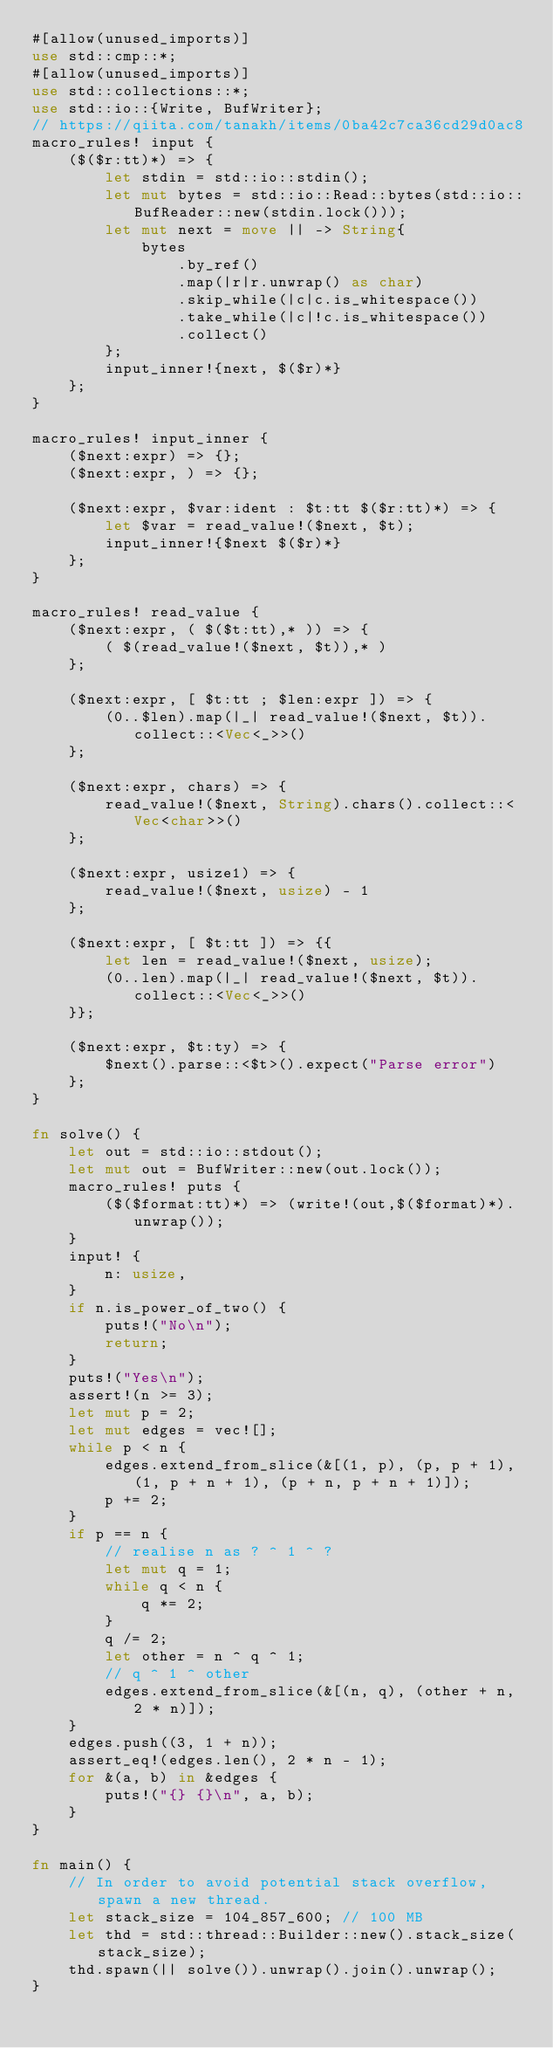<code> <loc_0><loc_0><loc_500><loc_500><_Rust_>#[allow(unused_imports)]
use std::cmp::*;
#[allow(unused_imports)]
use std::collections::*;
use std::io::{Write, BufWriter};
// https://qiita.com/tanakh/items/0ba42c7ca36cd29d0ac8
macro_rules! input {
    ($($r:tt)*) => {
        let stdin = std::io::stdin();
        let mut bytes = std::io::Read::bytes(std::io::BufReader::new(stdin.lock()));
        let mut next = move || -> String{
            bytes
                .by_ref()
                .map(|r|r.unwrap() as char)
                .skip_while(|c|c.is_whitespace())
                .take_while(|c|!c.is_whitespace())
                .collect()
        };
        input_inner!{next, $($r)*}
    };
}

macro_rules! input_inner {
    ($next:expr) => {};
    ($next:expr, ) => {};

    ($next:expr, $var:ident : $t:tt $($r:tt)*) => {
        let $var = read_value!($next, $t);
        input_inner!{$next $($r)*}
    };
}

macro_rules! read_value {
    ($next:expr, ( $($t:tt),* )) => {
        ( $(read_value!($next, $t)),* )
    };

    ($next:expr, [ $t:tt ; $len:expr ]) => {
        (0..$len).map(|_| read_value!($next, $t)).collect::<Vec<_>>()
    };

    ($next:expr, chars) => {
        read_value!($next, String).chars().collect::<Vec<char>>()
    };

    ($next:expr, usize1) => {
        read_value!($next, usize) - 1
    };

    ($next:expr, [ $t:tt ]) => {{
        let len = read_value!($next, usize);
        (0..len).map(|_| read_value!($next, $t)).collect::<Vec<_>>()
    }};

    ($next:expr, $t:ty) => {
        $next().parse::<$t>().expect("Parse error")
    };
}

fn solve() {
    let out = std::io::stdout();
    let mut out = BufWriter::new(out.lock());
    macro_rules! puts {
        ($($format:tt)*) => (write!(out,$($format)*).unwrap());
    }
    input! {
        n: usize,
    }
    if n.is_power_of_two() {
        puts!("No\n");
        return;
    }
    puts!("Yes\n");
    assert!(n >= 3);
    let mut p = 2;
    let mut edges = vec![];
    while p < n {
        edges.extend_from_slice(&[(1, p), (p, p + 1), (1, p + n + 1), (p + n, p + n + 1)]);
        p += 2;
    }
    if p == n {
        // realise n as ? ^ 1 ^ ?
        let mut q = 1;
        while q < n {
            q *= 2;
        }
        q /= 2;
        let other = n ^ q ^ 1;
        // q ^ 1 ^ other
        edges.extend_from_slice(&[(n, q), (other + n, 2 * n)]);
    }
    edges.push((3, 1 + n));
    assert_eq!(edges.len(), 2 * n - 1);
    for &(a, b) in &edges {
        puts!("{} {}\n", a, b);
    }
}

fn main() {
    // In order to avoid potential stack overflow, spawn a new thread.
    let stack_size = 104_857_600; // 100 MB
    let thd = std::thread::Builder::new().stack_size(stack_size);
    thd.spawn(|| solve()).unwrap().join().unwrap();
}
</code> 